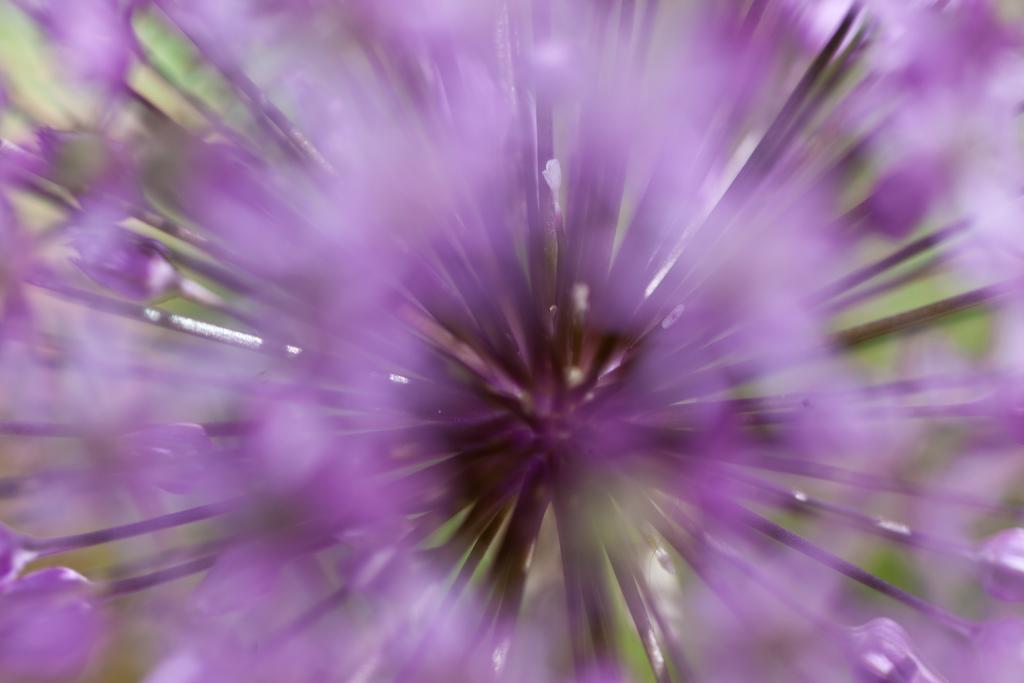How would you summarize this image in a sentence or two? Here in this picture we can see a close up view of a flower present. 